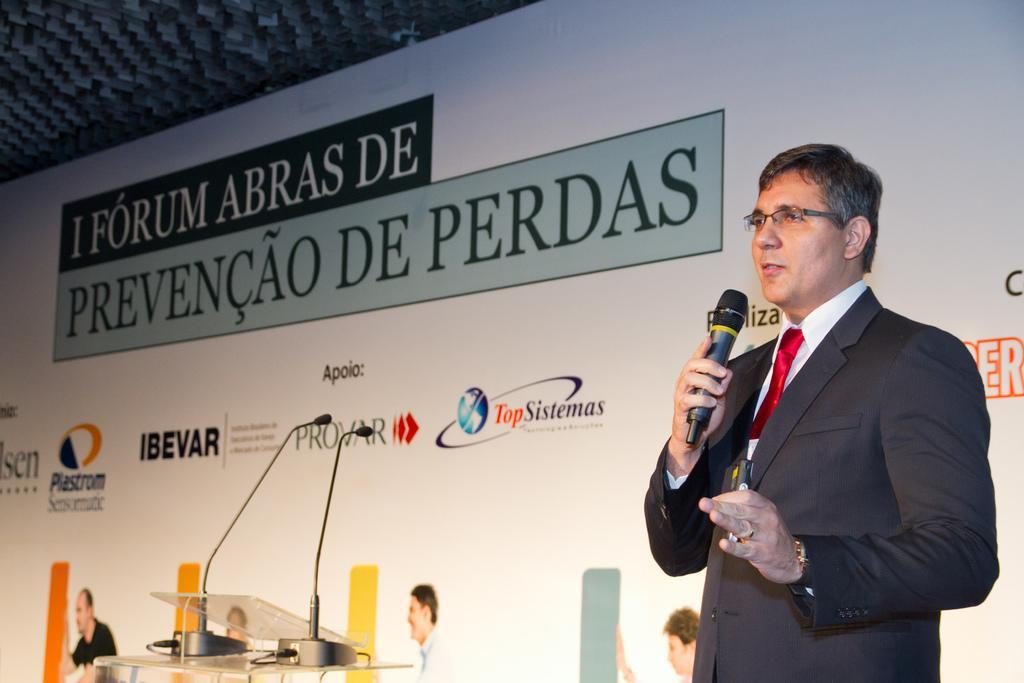Can you describe this image briefly? On the right side, there is a person in a suit, holding a microphone, wearing a spectacle, speaking and standing. On the left side, there are two microphones arranged on a stand. In the background, there is a banner and a roof. 